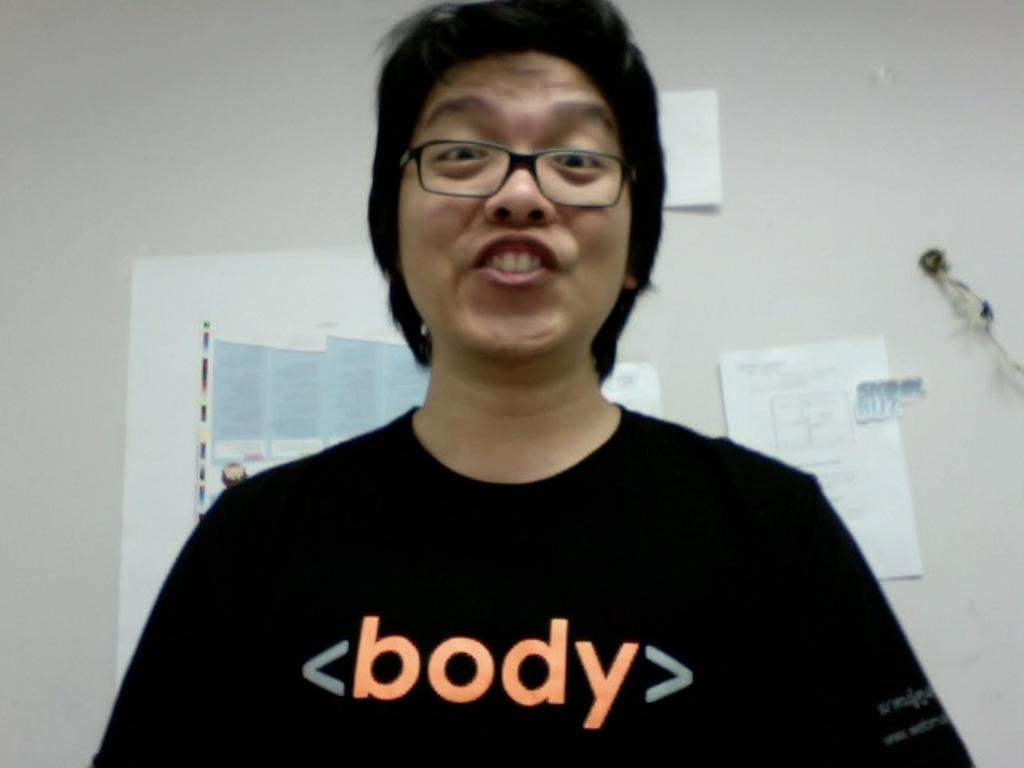What is the main subject of the image? There is a person in the image. What is the person wearing? The person is wearing a black color t-shirt. Are there any accessories visible on the person? Yes, the person is wearing spectacles. What is the person's facial expression? The person is smiling. What can be seen in the background of the image? There are posters in the background of the image. What is the color of the wall behind the posters? The posters are attached to a white wall. How many fish can be seen swimming in the image? There are no fish present in the image. What type of secretary is assisting the person in the image? There is no secretary present in the image. 